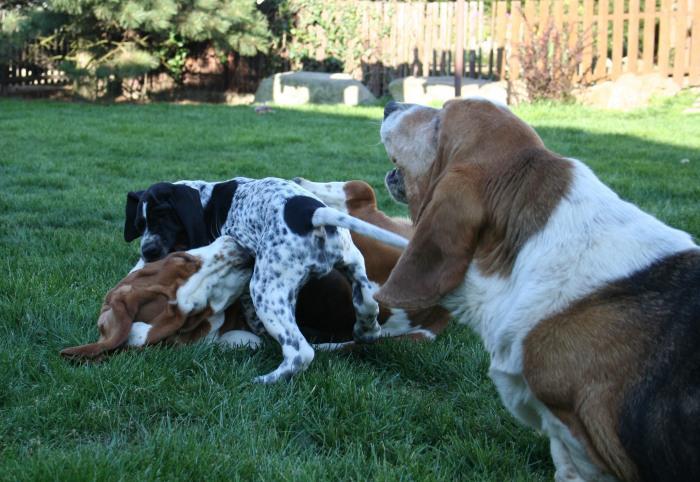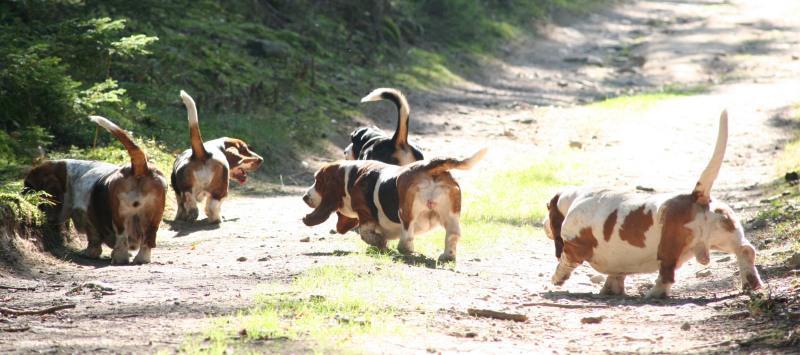The first image is the image on the left, the second image is the image on the right. Considering the images on both sides, is "All dogs are moving away from the camera in one image." valid? Answer yes or no. Yes. The first image is the image on the left, the second image is the image on the right. Assess this claim about the two images: "Dogs are playing in at least one of the images.". Correct or not? Answer yes or no. Yes. 